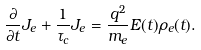Convert formula to latex. <formula><loc_0><loc_0><loc_500><loc_500>\frac { \partial } { \partial t } { J _ { e } } + \frac { 1 } { \tau _ { c } } J _ { e } = \frac { q ^ { 2 } } { m _ { e } } E ( t ) \rho _ { e } ( t ) .</formula> 